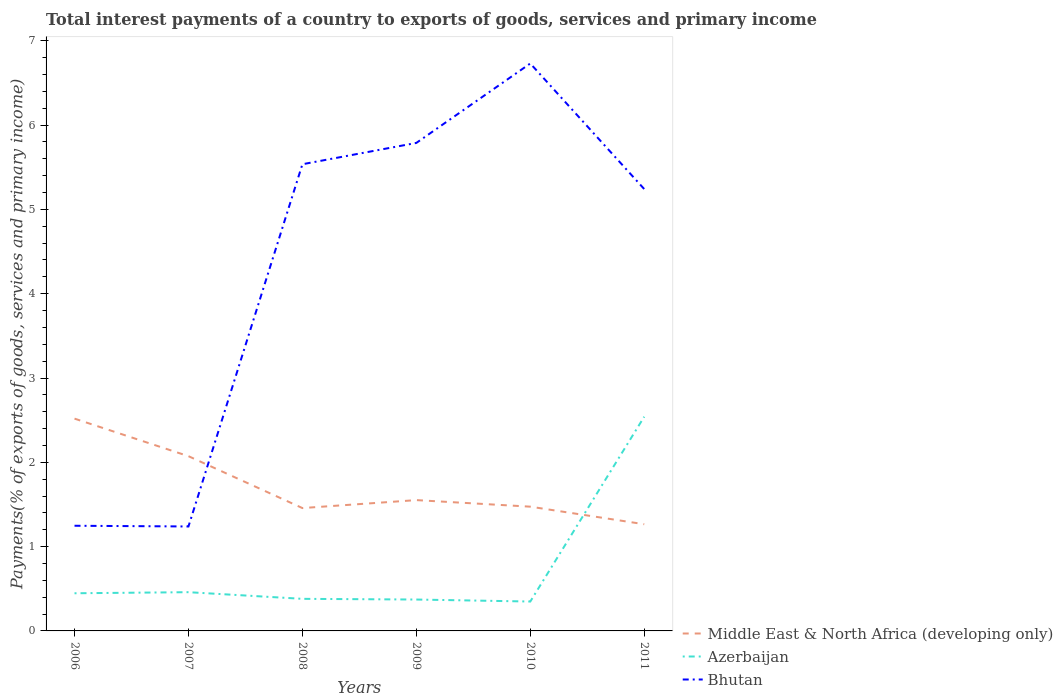Across all years, what is the maximum total interest payments in Bhutan?
Offer a very short reply. 1.24. What is the total total interest payments in Azerbaijan in the graph?
Offer a terse response. 0.1. What is the difference between the highest and the second highest total interest payments in Bhutan?
Offer a very short reply. 5.49. What is the difference between the highest and the lowest total interest payments in Bhutan?
Offer a very short reply. 4. How many lines are there?
Offer a very short reply. 3. How many years are there in the graph?
Provide a short and direct response. 6. Are the values on the major ticks of Y-axis written in scientific E-notation?
Your answer should be compact. No. Does the graph contain any zero values?
Provide a short and direct response. No. Does the graph contain grids?
Offer a terse response. No. How many legend labels are there?
Provide a short and direct response. 3. How are the legend labels stacked?
Your answer should be compact. Vertical. What is the title of the graph?
Your answer should be compact. Total interest payments of a country to exports of goods, services and primary income. What is the label or title of the Y-axis?
Give a very brief answer. Payments(% of exports of goods, services and primary income). What is the Payments(% of exports of goods, services and primary income) of Middle East & North Africa (developing only) in 2006?
Keep it short and to the point. 2.52. What is the Payments(% of exports of goods, services and primary income) in Azerbaijan in 2006?
Provide a succinct answer. 0.45. What is the Payments(% of exports of goods, services and primary income) of Bhutan in 2006?
Offer a terse response. 1.25. What is the Payments(% of exports of goods, services and primary income) of Middle East & North Africa (developing only) in 2007?
Provide a short and direct response. 2.07. What is the Payments(% of exports of goods, services and primary income) of Azerbaijan in 2007?
Your response must be concise. 0.46. What is the Payments(% of exports of goods, services and primary income) of Bhutan in 2007?
Provide a succinct answer. 1.24. What is the Payments(% of exports of goods, services and primary income) in Middle East & North Africa (developing only) in 2008?
Your answer should be compact. 1.46. What is the Payments(% of exports of goods, services and primary income) in Azerbaijan in 2008?
Offer a very short reply. 0.38. What is the Payments(% of exports of goods, services and primary income) in Bhutan in 2008?
Give a very brief answer. 5.54. What is the Payments(% of exports of goods, services and primary income) of Middle East & North Africa (developing only) in 2009?
Make the answer very short. 1.55. What is the Payments(% of exports of goods, services and primary income) of Azerbaijan in 2009?
Ensure brevity in your answer.  0.37. What is the Payments(% of exports of goods, services and primary income) of Bhutan in 2009?
Ensure brevity in your answer.  5.79. What is the Payments(% of exports of goods, services and primary income) of Middle East & North Africa (developing only) in 2010?
Offer a very short reply. 1.47. What is the Payments(% of exports of goods, services and primary income) in Azerbaijan in 2010?
Provide a short and direct response. 0.35. What is the Payments(% of exports of goods, services and primary income) of Bhutan in 2010?
Your response must be concise. 6.73. What is the Payments(% of exports of goods, services and primary income) of Middle East & North Africa (developing only) in 2011?
Your response must be concise. 1.27. What is the Payments(% of exports of goods, services and primary income) in Azerbaijan in 2011?
Your answer should be very brief. 2.54. What is the Payments(% of exports of goods, services and primary income) of Bhutan in 2011?
Provide a short and direct response. 5.24. Across all years, what is the maximum Payments(% of exports of goods, services and primary income) in Middle East & North Africa (developing only)?
Ensure brevity in your answer.  2.52. Across all years, what is the maximum Payments(% of exports of goods, services and primary income) in Azerbaijan?
Offer a terse response. 2.54. Across all years, what is the maximum Payments(% of exports of goods, services and primary income) of Bhutan?
Provide a succinct answer. 6.73. Across all years, what is the minimum Payments(% of exports of goods, services and primary income) in Middle East & North Africa (developing only)?
Your answer should be compact. 1.27. Across all years, what is the minimum Payments(% of exports of goods, services and primary income) in Azerbaijan?
Your answer should be very brief. 0.35. Across all years, what is the minimum Payments(% of exports of goods, services and primary income) of Bhutan?
Your answer should be very brief. 1.24. What is the total Payments(% of exports of goods, services and primary income) in Middle East & North Africa (developing only) in the graph?
Offer a very short reply. 10.34. What is the total Payments(% of exports of goods, services and primary income) in Azerbaijan in the graph?
Offer a very short reply. 4.55. What is the total Payments(% of exports of goods, services and primary income) in Bhutan in the graph?
Ensure brevity in your answer.  25.78. What is the difference between the Payments(% of exports of goods, services and primary income) of Middle East & North Africa (developing only) in 2006 and that in 2007?
Your answer should be compact. 0.45. What is the difference between the Payments(% of exports of goods, services and primary income) of Azerbaijan in 2006 and that in 2007?
Your answer should be very brief. -0.01. What is the difference between the Payments(% of exports of goods, services and primary income) in Bhutan in 2006 and that in 2007?
Make the answer very short. 0.01. What is the difference between the Payments(% of exports of goods, services and primary income) of Middle East & North Africa (developing only) in 2006 and that in 2008?
Your response must be concise. 1.06. What is the difference between the Payments(% of exports of goods, services and primary income) in Azerbaijan in 2006 and that in 2008?
Provide a short and direct response. 0.07. What is the difference between the Payments(% of exports of goods, services and primary income) in Bhutan in 2006 and that in 2008?
Provide a short and direct response. -4.29. What is the difference between the Payments(% of exports of goods, services and primary income) in Middle East & North Africa (developing only) in 2006 and that in 2009?
Keep it short and to the point. 0.97. What is the difference between the Payments(% of exports of goods, services and primary income) of Azerbaijan in 2006 and that in 2009?
Provide a succinct answer. 0.07. What is the difference between the Payments(% of exports of goods, services and primary income) in Bhutan in 2006 and that in 2009?
Offer a very short reply. -4.54. What is the difference between the Payments(% of exports of goods, services and primary income) in Middle East & North Africa (developing only) in 2006 and that in 2010?
Ensure brevity in your answer.  1.04. What is the difference between the Payments(% of exports of goods, services and primary income) in Azerbaijan in 2006 and that in 2010?
Provide a short and direct response. 0.1. What is the difference between the Payments(% of exports of goods, services and primary income) of Bhutan in 2006 and that in 2010?
Ensure brevity in your answer.  -5.48. What is the difference between the Payments(% of exports of goods, services and primary income) of Middle East & North Africa (developing only) in 2006 and that in 2011?
Provide a short and direct response. 1.25. What is the difference between the Payments(% of exports of goods, services and primary income) in Azerbaijan in 2006 and that in 2011?
Ensure brevity in your answer.  -2.09. What is the difference between the Payments(% of exports of goods, services and primary income) of Bhutan in 2006 and that in 2011?
Your answer should be compact. -3.99. What is the difference between the Payments(% of exports of goods, services and primary income) of Middle East & North Africa (developing only) in 2007 and that in 2008?
Offer a terse response. 0.62. What is the difference between the Payments(% of exports of goods, services and primary income) in Azerbaijan in 2007 and that in 2008?
Give a very brief answer. 0.08. What is the difference between the Payments(% of exports of goods, services and primary income) in Bhutan in 2007 and that in 2008?
Your response must be concise. -4.3. What is the difference between the Payments(% of exports of goods, services and primary income) of Middle East & North Africa (developing only) in 2007 and that in 2009?
Ensure brevity in your answer.  0.52. What is the difference between the Payments(% of exports of goods, services and primary income) of Azerbaijan in 2007 and that in 2009?
Provide a short and direct response. 0.09. What is the difference between the Payments(% of exports of goods, services and primary income) of Bhutan in 2007 and that in 2009?
Offer a very short reply. -4.55. What is the difference between the Payments(% of exports of goods, services and primary income) of Middle East & North Africa (developing only) in 2007 and that in 2010?
Keep it short and to the point. 0.6. What is the difference between the Payments(% of exports of goods, services and primary income) in Azerbaijan in 2007 and that in 2010?
Your response must be concise. 0.11. What is the difference between the Payments(% of exports of goods, services and primary income) of Bhutan in 2007 and that in 2010?
Offer a very short reply. -5.49. What is the difference between the Payments(% of exports of goods, services and primary income) of Middle East & North Africa (developing only) in 2007 and that in 2011?
Make the answer very short. 0.81. What is the difference between the Payments(% of exports of goods, services and primary income) in Azerbaijan in 2007 and that in 2011?
Provide a succinct answer. -2.08. What is the difference between the Payments(% of exports of goods, services and primary income) of Bhutan in 2007 and that in 2011?
Keep it short and to the point. -4. What is the difference between the Payments(% of exports of goods, services and primary income) in Middle East & North Africa (developing only) in 2008 and that in 2009?
Offer a very short reply. -0.09. What is the difference between the Payments(% of exports of goods, services and primary income) in Azerbaijan in 2008 and that in 2009?
Your answer should be compact. 0.01. What is the difference between the Payments(% of exports of goods, services and primary income) of Bhutan in 2008 and that in 2009?
Offer a terse response. -0.25. What is the difference between the Payments(% of exports of goods, services and primary income) of Middle East & North Africa (developing only) in 2008 and that in 2010?
Offer a very short reply. -0.02. What is the difference between the Payments(% of exports of goods, services and primary income) of Azerbaijan in 2008 and that in 2010?
Keep it short and to the point. 0.03. What is the difference between the Payments(% of exports of goods, services and primary income) of Bhutan in 2008 and that in 2010?
Offer a terse response. -1.2. What is the difference between the Payments(% of exports of goods, services and primary income) in Middle East & North Africa (developing only) in 2008 and that in 2011?
Your answer should be compact. 0.19. What is the difference between the Payments(% of exports of goods, services and primary income) of Azerbaijan in 2008 and that in 2011?
Your response must be concise. -2.16. What is the difference between the Payments(% of exports of goods, services and primary income) of Bhutan in 2008 and that in 2011?
Your answer should be compact. 0.29. What is the difference between the Payments(% of exports of goods, services and primary income) in Middle East & North Africa (developing only) in 2009 and that in 2010?
Keep it short and to the point. 0.08. What is the difference between the Payments(% of exports of goods, services and primary income) in Azerbaijan in 2009 and that in 2010?
Your response must be concise. 0.02. What is the difference between the Payments(% of exports of goods, services and primary income) in Bhutan in 2009 and that in 2010?
Give a very brief answer. -0.94. What is the difference between the Payments(% of exports of goods, services and primary income) of Middle East & North Africa (developing only) in 2009 and that in 2011?
Provide a short and direct response. 0.29. What is the difference between the Payments(% of exports of goods, services and primary income) of Azerbaijan in 2009 and that in 2011?
Give a very brief answer. -2.17. What is the difference between the Payments(% of exports of goods, services and primary income) in Bhutan in 2009 and that in 2011?
Offer a terse response. 0.55. What is the difference between the Payments(% of exports of goods, services and primary income) in Middle East & North Africa (developing only) in 2010 and that in 2011?
Provide a succinct answer. 0.21. What is the difference between the Payments(% of exports of goods, services and primary income) in Azerbaijan in 2010 and that in 2011?
Provide a short and direct response. -2.19. What is the difference between the Payments(% of exports of goods, services and primary income) in Bhutan in 2010 and that in 2011?
Your answer should be very brief. 1.49. What is the difference between the Payments(% of exports of goods, services and primary income) of Middle East & North Africa (developing only) in 2006 and the Payments(% of exports of goods, services and primary income) of Azerbaijan in 2007?
Give a very brief answer. 2.06. What is the difference between the Payments(% of exports of goods, services and primary income) in Middle East & North Africa (developing only) in 2006 and the Payments(% of exports of goods, services and primary income) in Bhutan in 2007?
Your answer should be very brief. 1.28. What is the difference between the Payments(% of exports of goods, services and primary income) in Azerbaijan in 2006 and the Payments(% of exports of goods, services and primary income) in Bhutan in 2007?
Offer a terse response. -0.79. What is the difference between the Payments(% of exports of goods, services and primary income) in Middle East & North Africa (developing only) in 2006 and the Payments(% of exports of goods, services and primary income) in Azerbaijan in 2008?
Give a very brief answer. 2.14. What is the difference between the Payments(% of exports of goods, services and primary income) in Middle East & North Africa (developing only) in 2006 and the Payments(% of exports of goods, services and primary income) in Bhutan in 2008?
Your answer should be very brief. -3.02. What is the difference between the Payments(% of exports of goods, services and primary income) of Azerbaijan in 2006 and the Payments(% of exports of goods, services and primary income) of Bhutan in 2008?
Give a very brief answer. -5.09. What is the difference between the Payments(% of exports of goods, services and primary income) in Middle East & North Africa (developing only) in 2006 and the Payments(% of exports of goods, services and primary income) in Azerbaijan in 2009?
Provide a short and direct response. 2.15. What is the difference between the Payments(% of exports of goods, services and primary income) in Middle East & North Africa (developing only) in 2006 and the Payments(% of exports of goods, services and primary income) in Bhutan in 2009?
Give a very brief answer. -3.27. What is the difference between the Payments(% of exports of goods, services and primary income) in Azerbaijan in 2006 and the Payments(% of exports of goods, services and primary income) in Bhutan in 2009?
Give a very brief answer. -5.34. What is the difference between the Payments(% of exports of goods, services and primary income) of Middle East & North Africa (developing only) in 2006 and the Payments(% of exports of goods, services and primary income) of Azerbaijan in 2010?
Keep it short and to the point. 2.17. What is the difference between the Payments(% of exports of goods, services and primary income) of Middle East & North Africa (developing only) in 2006 and the Payments(% of exports of goods, services and primary income) of Bhutan in 2010?
Provide a succinct answer. -4.21. What is the difference between the Payments(% of exports of goods, services and primary income) of Azerbaijan in 2006 and the Payments(% of exports of goods, services and primary income) of Bhutan in 2010?
Ensure brevity in your answer.  -6.28. What is the difference between the Payments(% of exports of goods, services and primary income) of Middle East & North Africa (developing only) in 2006 and the Payments(% of exports of goods, services and primary income) of Azerbaijan in 2011?
Your answer should be compact. -0.02. What is the difference between the Payments(% of exports of goods, services and primary income) of Middle East & North Africa (developing only) in 2006 and the Payments(% of exports of goods, services and primary income) of Bhutan in 2011?
Offer a very short reply. -2.72. What is the difference between the Payments(% of exports of goods, services and primary income) of Azerbaijan in 2006 and the Payments(% of exports of goods, services and primary income) of Bhutan in 2011?
Your answer should be compact. -4.79. What is the difference between the Payments(% of exports of goods, services and primary income) in Middle East & North Africa (developing only) in 2007 and the Payments(% of exports of goods, services and primary income) in Azerbaijan in 2008?
Your answer should be very brief. 1.69. What is the difference between the Payments(% of exports of goods, services and primary income) of Middle East & North Africa (developing only) in 2007 and the Payments(% of exports of goods, services and primary income) of Bhutan in 2008?
Ensure brevity in your answer.  -3.46. What is the difference between the Payments(% of exports of goods, services and primary income) of Azerbaijan in 2007 and the Payments(% of exports of goods, services and primary income) of Bhutan in 2008?
Your response must be concise. -5.08. What is the difference between the Payments(% of exports of goods, services and primary income) in Middle East & North Africa (developing only) in 2007 and the Payments(% of exports of goods, services and primary income) in Azerbaijan in 2009?
Your response must be concise. 1.7. What is the difference between the Payments(% of exports of goods, services and primary income) of Middle East & North Africa (developing only) in 2007 and the Payments(% of exports of goods, services and primary income) of Bhutan in 2009?
Your answer should be very brief. -3.72. What is the difference between the Payments(% of exports of goods, services and primary income) of Azerbaijan in 2007 and the Payments(% of exports of goods, services and primary income) of Bhutan in 2009?
Ensure brevity in your answer.  -5.33. What is the difference between the Payments(% of exports of goods, services and primary income) in Middle East & North Africa (developing only) in 2007 and the Payments(% of exports of goods, services and primary income) in Azerbaijan in 2010?
Ensure brevity in your answer.  1.72. What is the difference between the Payments(% of exports of goods, services and primary income) in Middle East & North Africa (developing only) in 2007 and the Payments(% of exports of goods, services and primary income) in Bhutan in 2010?
Provide a succinct answer. -4.66. What is the difference between the Payments(% of exports of goods, services and primary income) in Azerbaijan in 2007 and the Payments(% of exports of goods, services and primary income) in Bhutan in 2010?
Offer a very short reply. -6.27. What is the difference between the Payments(% of exports of goods, services and primary income) in Middle East & North Africa (developing only) in 2007 and the Payments(% of exports of goods, services and primary income) in Azerbaijan in 2011?
Offer a very short reply. -0.47. What is the difference between the Payments(% of exports of goods, services and primary income) in Middle East & North Africa (developing only) in 2007 and the Payments(% of exports of goods, services and primary income) in Bhutan in 2011?
Your answer should be very brief. -3.17. What is the difference between the Payments(% of exports of goods, services and primary income) of Azerbaijan in 2007 and the Payments(% of exports of goods, services and primary income) of Bhutan in 2011?
Provide a succinct answer. -4.78. What is the difference between the Payments(% of exports of goods, services and primary income) of Middle East & North Africa (developing only) in 2008 and the Payments(% of exports of goods, services and primary income) of Azerbaijan in 2009?
Make the answer very short. 1.08. What is the difference between the Payments(% of exports of goods, services and primary income) in Middle East & North Africa (developing only) in 2008 and the Payments(% of exports of goods, services and primary income) in Bhutan in 2009?
Keep it short and to the point. -4.33. What is the difference between the Payments(% of exports of goods, services and primary income) of Azerbaijan in 2008 and the Payments(% of exports of goods, services and primary income) of Bhutan in 2009?
Keep it short and to the point. -5.41. What is the difference between the Payments(% of exports of goods, services and primary income) in Middle East & North Africa (developing only) in 2008 and the Payments(% of exports of goods, services and primary income) in Azerbaijan in 2010?
Offer a terse response. 1.11. What is the difference between the Payments(% of exports of goods, services and primary income) in Middle East & North Africa (developing only) in 2008 and the Payments(% of exports of goods, services and primary income) in Bhutan in 2010?
Make the answer very short. -5.27. What is the difference between the Payments(% of exports of goods, services and primary income) in Azerbaijan in 2008 and the Payments(% of exports of goods, services and primary income) in Bhutan in 2010?
Offer a terse response. -6.35. What is the difference between the Payments(% of exports of goods, services and primary income) of Middle East & North Africa (developing only) in 2008 and the Payments(% of exports of goods, services and primary income) of Azerbaijan in 2011?
Ensure brevity in your answer.  -1.08. What is the difference between the Payments(% of exports of goods, services and primary income) in Middle East & North Africa (developing only) in 2008 and the Payments(% of exports of goods, services and primary income) in Bhutan in 2011?
Provide a succinct answer. -3.78. What is the difference between the Payments(% of exports of goods, services and primary income) of Azerbaijan in 2008 and the Payments(% of exports of goods, services and primary income) of Bhutan in 2011?
Your response must be concise. -4.86. What is the difference between the Payments(% of exports of goods, services and primary income) in Middle East & North Africa (developing only) in 2009 and the Payments(% of exports of goods, services and primary income) in Azerbaijan in 2010?
Give a very brief answer. 1.2. What is the difference between the Payments(% of exports of goods, services and primary income) in Middle East & North Africa (developing only) in 2009 and the Payments(% of exports of goods, services and primary income) in Bhutan in 2010?
Make the answer very short. -5.18. What is the difference between the Payments(% of exports of goods, services and primary income) in Azerbaijan in 2009 and the Payments(% of exports of goods, services and primary income) in Bhutan in 2010?
Offer a very short reply. -6.36. What is the difference between the Payments(% of exports of goods, services and primary income) of Middle East & North Africa (developing only) in 2009 and the Payments(% of exports of goods, services and primary income) of Azerbaijan in 2011?
Provide a short and direct response. -0.99. What is the difference between the Payments(% of exports of goods, services and primary income) of Middle East & North Africa (developing only) in 2009 and the Payments(% of exports of goods, services and primary income) of Bhutan in 2011?
Your answer should be compact. -3.69. What is the difference between the Payments(% of exports of goods, services and primary income) in Azerbaijan in 2009 and the Payments(% of exports of goods, services and primary income) in Bhutan in 2011?
Give a very brief answer. -4.87. What is the difference between the Payments(% of exports of goods, services and primary income) in Middle East & North Africa (developing only) in 2010 and the Payments(% of exports of goods, services and primary income) in Azerbaijan in 2011?
Your answer should be compact. -1.07. What is the difference between the Payments(% of exports of goods, services and primary income) in Middle East & North Africa (developing only) in 2010 and the Payments(% of exports of goods, services and primary income) in Bhutan in 2011?
Provide a succinct answer. -3.77. What is the difference between the Payments(% of exports of goods, services and primary income) in Azerbaijan in 2010 and the Payments(% of exports of goods, services and primary income) in Bhutan in 2011?
Offer a terse response. -4.89. What is the average Payments(% of exports of goods, services and primary income) of Middle East & North Africa (developing only) per year?
Provide a short and direct response. 1.72. What is the average Payments(% of exports of goods, services and primary income) of Azerbaijan per year?
Your answer should be compact. 0.76. What is the average Payments(% of exports of goods, services and primary income) in Bhutan per year?
Keep it short and to the point. 4.3. In the year 2006, what is the difference between the Payments(% of exports of goods, services and primary income) in Middle East & North Africa (developing only) and Payments(% of exports of goods, services and primary income) in Azerbaijan?
Make the answer very short. 2.07. In the year 2006, what is the difference between the Payments(% of exports of goods, services and primary income) of Middle East & North Africa (developing only) and Payments(% of exports of goods, services and primary income) of Bhutan?
Ensure brevity in your answer.  1.27. In the year 2006, what is the difference between the Payments(% of exports of goods, services and primary income) of Azerbaijan and Payments(% of exports of goods, services and primary income) of Bhutan?
Make the answer very short. -0.8. In the year 2007, what is the difference between the Payments(% of exports of goods, services and primary income) in Middle East & North Africa (developing only) and Payments(% of exports of goods, services and primary income) in Azerbaijan?
Give a very brief answer. 1.61. In the year 2007, what is the difference between the Payments(% of exports of goods, services and primary income) in Middle East & North Africa (developing only) and Payments(% of exports of goods, services and primary income) in Bhutan?
Provide a short and direct response. 0.83. In the year 2007, what is the difference between the Payments(% of exports of goods, services and primary income) of Azerbaijan and Payments(% of exports of goods, services and primary income) of Bhutan?
Give a very brief answer. -0.78. In the year 2008, what is the difference between the Payments(% of exports of goods, services and primary income) in Middle East & North Africa (developing only) and Payments(% of exports of goods, services and primary income) in Azerbaijan?
Your answer should be very brief. 1.08. In the year 2008, what is the difference between the Payments(% of exports of goods, services and primary income) of Middle East & North Africa (developing only) and Payments(% of exports of goods, services and primary income) of Bhutan?
Offer a very short reply. -4.08. In the year 2008, what is the difference between the Payments(% of exports of goods, services and primary income) in Azerbaijan and Payments(% of exports of goods, services and primary income) in Bhutan?
Give a very brief answer. -5.16. In the year 2009, what is the difference between the Payments(% of exports of goods, services and primary income) in Middle East & North Africa (developing only) and Payments(% of exports of goods, services and primary income) in Azerbaijan?
Make the answer very short. 1.18. In the year 2009, what is the difference between the Payments(% of exports of goods, services and primary income) of Middle East & North Africa (developing only) and Payments(% of exports of goods, services and primary income) of Bhutan?
Offer a very short reply. -4.24. In the year 2009, what is the difference between the Payments(% of exports of goods, services and primary income) of Azerbaijan and Payments(% of exports of goods, services and primary income) of Bhutan?
Offer a very short reply. -5.42. In the year 2010, what is the difference between the Payments(% of exports of goods, services and primary income) of Middle East & North Africa (developing only) and Payments(% of exports of goods, services and primary income) of Azerbaijan?
Ensure brevity in your answer.  1.13. In the year 2010, what is the difference between the Payments(% of exports of goods, services and primary income) in Middle East & North Africa (developing only) and Payments(% of exports of goods, services and primary income) in Bhutan?
Provide a short and direct response. -5.26. In the year 2010, what is the difference between the Payments(% of exports of goods, services and primary income) of Azerbaijan and Payments(% of exports of goods, services and primary income) of Bhutan?
Keep it short and to the point. -6.38. In the year 2011, what is the difference between the Payments(% of exports of goods, services and primary income) of Middle East & North Africa (developing only) and Payments(% of exports of goods, services and primary income) of Azerbaijan?
Make the answer very short. -1.28. In the year 2011, what is the difference between the Payments(% of exports of goods, services and primary income) of Middle East & North Africa (developing only) and Payments(% of exports of goods, services and primary income) of Bhutan?
Ensure brevity in your answer.  -3.98. In the year 2011, what is the difference between the Payments(% of exports of goods, services and primary income) of Azerbaijan and Payments(% of exports of goods, services and primary income) of Bhutan?
Offer a very short reply. -2.7. What is the ratio of the Payments(% of exports of goods, services and primary income) in Middle East & North Africa (developing only) in 2006 to that in 2007?
Your answer should be compact. 1.21. What is the ratio of the Payments(% of exports of goods, services and primary income) in Azerbaijan in 2006 to that in 2007?
Your answer should be very brief. 0.97. What is the ratio of the Payments(% of exports of goods, services and primary income) in Middle East & North Africa (developing only) in 2006 to that in 2008?
Make the answer very short. 1.73. What is the ratio of the Payments(% of exports of goods, services and primary income) of Azerbaijan in 2006 to that in 2008?
Your response must be concise. 1.17. What is the ratio of the Payments(% of exports of goods, services and primary income) of Bhutan in 2006 to that in 2008?
Offer a very short reply. 0.23. What is the ratio of the Payments(% of exports of goods, services and primary income) in Middle East & North Africa (developing only) in 2006 to that in 2009?
Offer a very short reply. 1.62. What is the ratio of the Payments(% of exports of goods, services and primary income) of Azerbaijan in 2006 to that in 2009?
Make the answer very short. 1.2. What is the ratio of the Payments(% of exports of goods, services and primary income) in Bhutan in 2006 to that in 2009?
Give a very brief answer. 0.22. What is the ratio of the Payments(% of exports of goods, services and primary income) of Middle East & North Africa (developing only) in 2006 to that in 2010?
Your response must be concise. 1.71. What is the ratio of the Payments(% of exports of goods, services and primary income) in Azerbaijan in 2006 to that in 2010?
Make the answer very short. 1.28. What is the ratio of the Payments(% of exports of goods, services and primary income) in Bhutan in 2006 to that in 2010?
Offer a very short reply. 0.19. What is the ratio of the Payments(% of exports of goods, services and primary income) in Middle East & North Africa (developing only) in 2006 to that in 2011?
Provide a succinct answer. 1.99. What is the ratio of the Payments(% of exports of goods, services and primary income) of Azerbaijan in 2006 to that in 2011?
Ensure brevity in your answer.  0.18. What is the ratio of the Payments(% of exports of goods, services and primary income) of Bhutan in 2006 to that in 2011?
Your answer should be compact. 0.24. What is the ratio of the Payments(% of exports of goods, services and primary income) in Middle East & North Africa (developing only) in 2007 to that in 2008?
Provide a succinct answer. 1.42. What is the ratio of the Payments(% of exports of goods, services and primary income) of Azerbaijan in 2007 to that in 2008?
Provide a succinct answer. 1.21. What is the ratio of the Payments(% of exports of goods, services and primary income) in Bhutan in 2007 to that in 2008?
Offer a terse response. 0.22. What is the ratio of the Payments(% of exports of goods, services and primary income) in Middle East & North Africa (developing only) in 2007 to that in 2009?
Your answer should be compact. 1.34. What is the ratio of the Payments(% of exports of goods, services and primary income) of Azerbaijan in 2007 to that in 2009?
Provide a short and direct response. 1.23. What is the ratio of the Payments(% of exports of goods, services and primary income) of Bhutan in 2007 to that in 2009?
Offer a terse response. 0.21. What is the ratio of the Payments(% of exports of goods, services and primary income) of Middle East & North Africa (developing only) in 2007 to that in 2010?
Make the answer very short. 1.41. What is the ratio of the Payments(% of exports of goods, services and primary income) of Azerbaijan in 2007 to that in 2010?
Provide a succinct answer. 1.32. What is the ratio of the Payments(% of exports of goods, services and primary income) in Bhutan in 2007 to that in 2010?
Your response must be concise. 0.18. What is the ratio of the Payments(% of exports of goods, services and primary income) in Middle East & North Africa (developing only) in 2007 to that in 2011?
Make the answer very short. 1.64. What is the ratio of the Payments(% of exports of goods, services and primary income) of Azerbaijan in 2007 to that in 2011?
Provide a succinct answer. 0.18. What is the ratio of the Payments(% of exports of goods, services and primary income) in Bhutan in 2007 to that in 2011?
Offer a terse response. 0.24. What is the ratio of the Payments(% of exports of goods, services and primary income) in Middle East & North Africa (developing only) in 2008 to that in 2009?
Offer a terse response. 0.94. What is the ratio of the Payments(% of exports of goods, services and primary income) of Azerbaijan in 2008 to that in 2009?
Make the answer very short. 1.02. What is the ratio of the Payments(% of exports of goods, services and primary income) of Bhutan in 2008 to that in 2009?
Keep it short and to the point. 0.96. What is the ratio of the Payments(% of exports of goods, services and primary income) of Middle East & North Africa (developing only) in 2008 to that in 2010?
Keep it short and to the point. 0.99. What is the ratio of the Payments(% of exports of goods, services and primary income) of Azerbaijan in 2008 to that in 2010?
Your answer should be compact. 1.09. What is the ratio of the Payments(% of exports of goods, services and primary income) of Bhutan in 2008 to that in 2010?
Make the answer very short. 0.82. What is the ratio of the Payments(% of exports of goods, services and primary income) in Middle East & North Africa (developing only) in 2008 to that in 2011?
Give a very brief answer. 1.15. What is the ratio of the Payments(% of exports of goods, services and primary income) of Azerbaijan in 2008 to that in 2011?
Your answer should be compact. 0.15. What is the ratio of the Payments(% of exports of goods, services and primary income) in Bhutan in 2008 to that in 2011?
Make the answer very short. 1.06. What is the ratio of the Payments(% of exports of goods, services and primary income) of Middle East & North Africa (developing only) in 2009 to that in 2010?
Your answer should be very brief. 1.05. What is the ratio of the Payments(% of exports of goods, services and primary income) in Azerbaijan in 2009 to that in 2010?
Give a very brief answer. 1.07. What is the ratio of the Payments(% of exports of goods, services and primary income) of Bhutan in 2009 to that in 2010?
Offer a very short reply. 0.86. What is the ratio of the Payments(% of exports of goods, services and primary income) of Middle East & North Africa (developing only) in 2009 to that in 2011?
Your response must be concise. 1.23. What is the ratio of the Payments(% of exports of goods, services and primary income) in Azerbaijan in 2009 to that in 2011?
Keep it short and to the point. 0.15. What is the ratio of the Payments(% of exports of goods, services and primary income) in Bhutan in 2009 to that in 2011?
Offer a terse response. 1.1. What is the ratio of the Payments(% of exports of goods, services and primary income) in Middle East & North Africa (developing only) in 2010 to that in 2011?
Provide a short and direct response. 1.16. What is the ratio of the Payments(% of exports of goods, services and primary income) in Azerbaijan in 2010 to that in 2011?
Your answer should be very brief. 0.14. What is the ratio of the Payments(% of exports of goods, services and primary income) in Bhutan in 2010 to that in 2011?
Offer a very short reply. 1.28. What is the difference between the highest and the second highest Payments(% of exports of goods, services and primary income) in Middle East & North Africa (developing only)?
Your answer should be very brief. 0.45. What is the difference between the highest and the second highest Payments(% of exports of goods, services and primary income) of Azerbaijan?
Offer a very short reply. 2.08. What is the difference between the highest and the second highest Payments(% of exports of goods, services and primary income) of Bhutan?
Make the answer very short. 0.94. What is the difference between the highest and the lowest Payments(% of exports of goods, services and primary income) in Middle East & North Africa (developing only)?
Provide a short and direct response. 1.25. What is the difference between the highest and the lowest Payments(% of exports of goods, services and primary income) in Azerbaijan?
Your answer should be very brief. 2.19. What is the difference between the highest and the lowest Payments(% of exports of goods, services and primary income) of Bhutan?
Offer a very short reply. 5.49. 